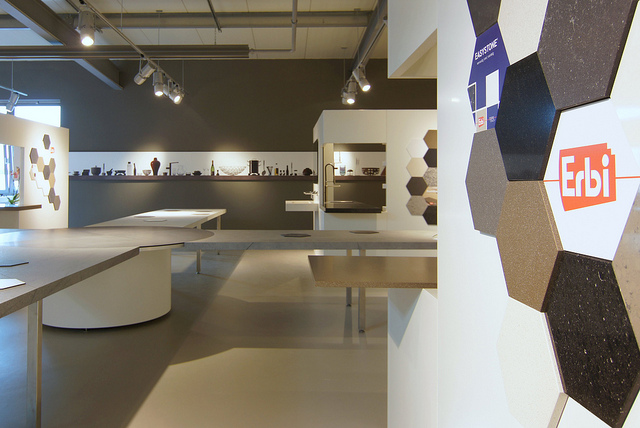Identify the text contained in this image. Erbi 